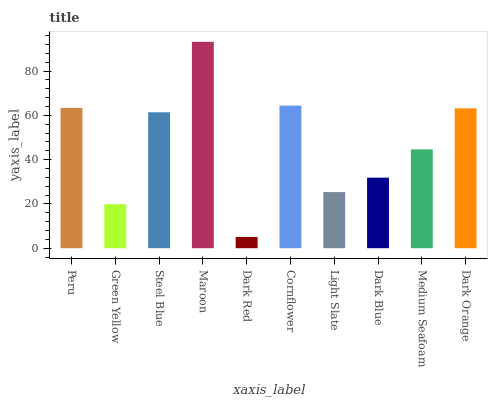Is Green Yellow the minimum?
Answer yes or no. No. Is Green Yellow the maximum?
Answer yes or no. No. Is Peru greater than Green Yellow?
Answer yes or no. Yes. Is Green Yellow less than Peru?
Answer yes or no. Yes. Is Green Yellow greater than Peru?
Answer yes or no. No. Is Peru less than Green Yellow?
Answer yes or no. No. Is Steel Blue the high median?
Answer yes or no. Yes. Is Medium Seafoam the low median?
Answer yes or no. Yes. Is Dark Red the high median?
Answer yes or no. No. Is Peru the low median?
Answer yes or no. No. 